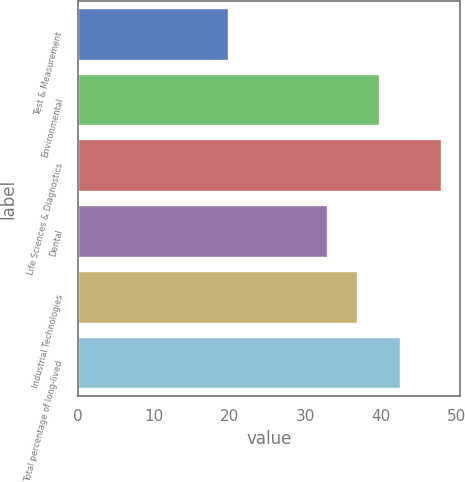Convert chart. <chart><loc_0><loc_0><loc_500><loc_500><bar_chart><fcel>Test & Measurement<fcel>Environmental<fcel>Life Sciences & Diagnostics<fcel>Dental<fcel>Industrial Technologies<fcel>Total percentage of long-lived<nl><fcel>20<fcel>39.8<fcel>48<fcel>33<fcel>37<fcel>42.6<nl></chart> 